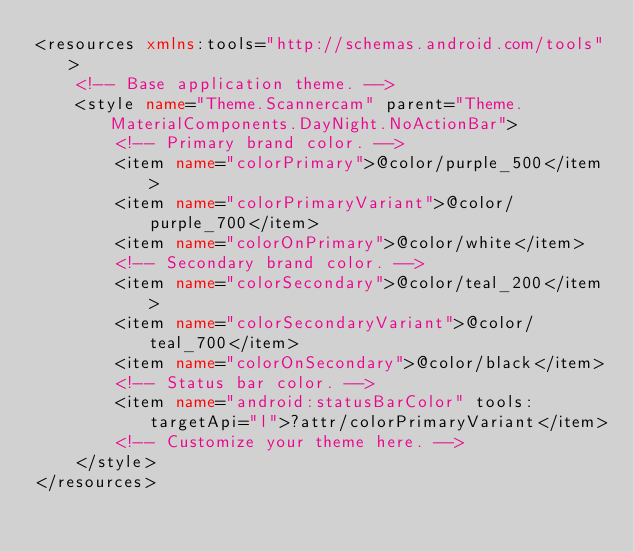Convert code to text. <code><loc_0><loc_0><loc_500><loc_500><_XML_><resources xmlns:tools="http://schemas.android.com/tools">
    <!-- Base application theme. -->
    <style name="Theme.Scannercam" parent="Theme.MaterialComponents.DayNight.NoActionBar">
        <!-- Primary brand color. -->
        <item name="colorPrimary">@color/purple_500</item>
        <item name="colorPrimaryVariant">@color/purple_700</item>
        <item name="colorOnPrimary">@color/white</item>
        <!-- Secondary brand color. -->
        <item name="colorSecondary">@color/teal_200</item>
        <item name="colorSecondaryVariant">@color/teal_700</item>
        <item name="colorOnSecondary">@color/black</item>
        <!-- Status bar color. -->
        <item name="android:statusBarColor" tools:targetApi="l">?attr/colorPrimaryVariant</item>
        <!-- Customize your theme here. -->
    </style>
</resources></code> 